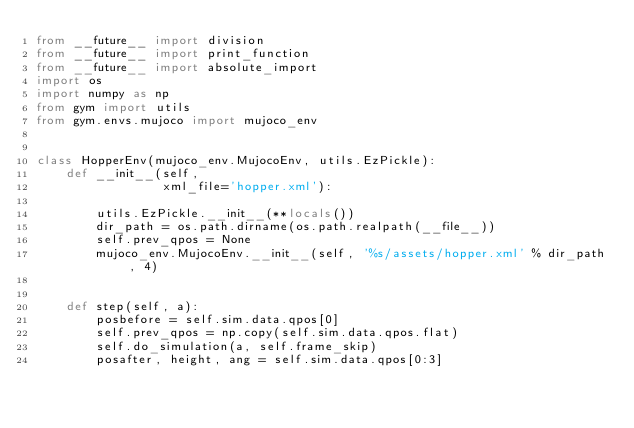<code> <loc_0><loc_0><loc_500><loc_500><_Python_>from __future__ import division
from __future__ import print_function
from __future__ import absolute_import
import os
import numpy as np
from gym import utils
from gym.envs.mujoco import mujoco_env


class HopperEnv(mujoco_env.MujocoEnv, utils.EzPickle):
    def __init__(self,
                 xml_file='hopper.xml'):

        utils.EzPickle.__init__(**locals())
        dir_path = os.path.dirname(os.path.realpath(__file__))
        self.prev_qpos = None
        mujoco_env.MujocoEnv.__init__(self, '%s/assets/hopper.xml' % dir_path, 4)
        

    def step(self, a):
        posbefore = self.sim.data.qpos[0]
        self.prev_qpos = np.copy(self.sim.data.qpos.flat)
        self.do_simulation(a, self.frame_skip)
        posafter, height, ang = self.sim.data.qpos[0:3]</code> 